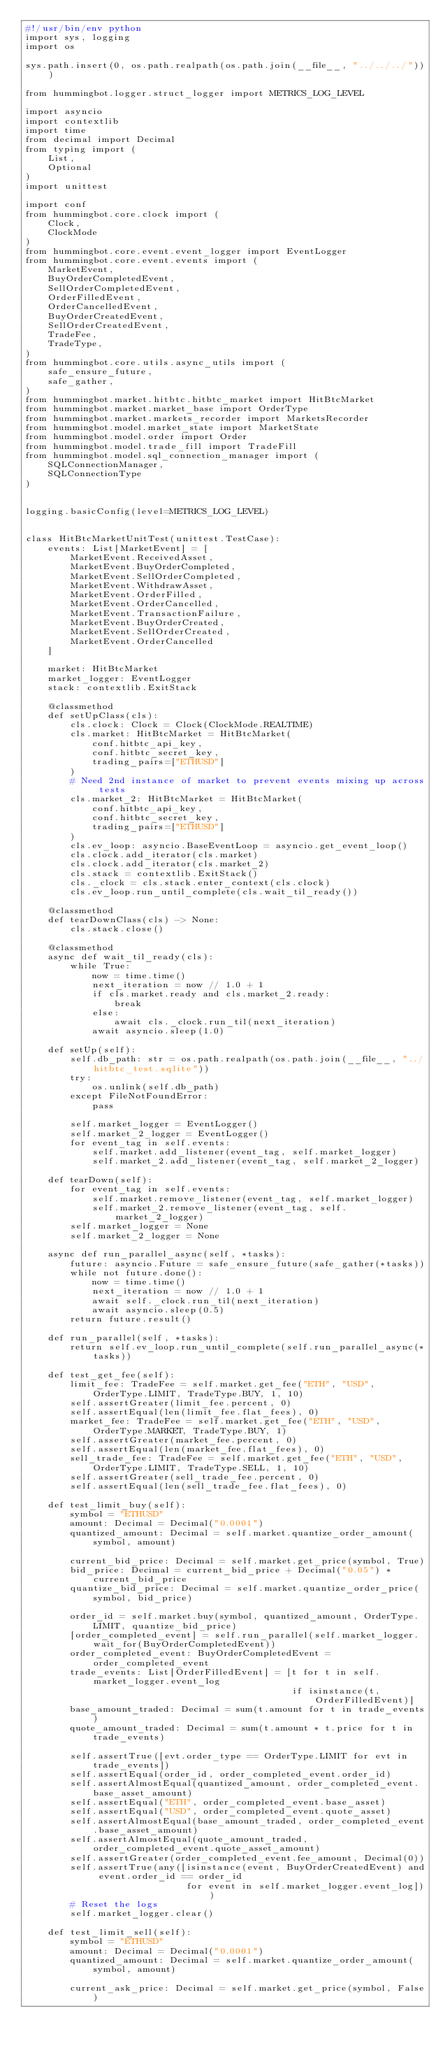<code> <loc_0><loc_0><loc_500><loc_500><_Python_>#!/usr/bin/env python
import sys, logging
import os

sys.path.insert(0, os.path.realpath(os.path.join(__file__, "../../../")))

from hummingbot.logger.struct_logger import METRICS_LOG_LEVEL

import asyncio
import contextlib
import time
from decimal import Decimal
from typing import (
    List,
    Optional
)
import unittest

import conf
from hummingbot.core.clock import (
    Clock,
    ClockMode
)
from hummingbot.core.event.event_logger import EventLogger
from hummingbot.core.event.events import (
    MarketEvent,
    BuyOrderCompletedEvent,
    SellOrderCompletedEvent,
    OrderFilledEvent,
    OrderCancelledEvent,
    BuyOrderCreatedEvent,
    SellOrderCreatedEvent,
    TradeFee,
    TradeType,
)
from hummingbot.core.utils.async_utils import (
    safe_ensure_future,
    safe_gather,
)
from hummingbot.market.hitbtc.hitbtc_market import HitBtcMarket
from hummingbot.market.market_base import OrderType
from hummingbot.market.markets_recorder import MarketsRecorder
from hummingbot.model.market_state import MarketState
from hummingbot.model.order import Order
from hummingbot.model.trade_fill import TradeFill
from hummingbot.model.sql_connection_manager import (
    SQLConnectionManager,
    SQLConnectionType
)


logging.basicConfig(level=METRICS_LOG_LEVEL)


class HitBtcMarketUnitTest(unittest.TestCase):
    events: List[MarketEvent] = [
        MarketEvent.ReceivedAsset,
        MarketEvent.BuyOrderCompleted,
        MarketEvent.SellOrderCompleted,
        MarketEvent.WithdrawAsset,
        MarketEvent.OrderFilled,
        MarketEvent.OrderCancelled,
        MarketEvent.TransactionFailure,
        MarketEvent.BuyOrderCreated,
        MarketEvent.SellOrderCreated,
        MarketEvent.OrderCancelled
    ]

    market: HitBtcMarket
    market_logger: EventLogger
    stack: contextlib.ExitStack

    @classmethod
    def setUpClass(cls):
        cls.clock: Clock = Clock(ClockMode.REALTIME)
        cls.market: HitBtcMarket = HitBtcMarket(
            conf.hitbtc_api_key,
            conf.hitbtc_secret_key,
            trading_pairs=["ETHUSD"]
        )
        # Need 2nd instance of market to prevent events mixing up across tests
        cls.market_2: HitBtcMarket = HitBtcMarket(
            conf.hitbtc_api_key,
            conf.hitbtc_secret_key,
            trading_pairs=["ETHUSD"]
        )
        cls.ev_loop: asyncio.BaseEventLoop = asyncio.get_event_loop()
        cls.clock.add_iterator(cls.market)
        cls.clock.add_iterator(cls.market_2)
        cls.stack = contextlib.ExitStack()
        cls._clock = cls.stack.enter_context(cls.clock)
        cls.ev_loop.run_until_complete(cls.wait_til_ready())

    @classmethod
    def tearDownClass(cls) -> None:
        cls.stack.close()

    @classmethod
    async def wait_til_ready(cls):
        while True:
            now = time.time()
            next_iteration = now // 1.0 + 1
            if cls.market.ready and cls.market_2.ready:
                break
            else:
                await cls._clock.run_til(next_iteration)
            await asyncio.sleep(1.0)

    def setUp(self):
        self.db_path: str = os.path.realpath(os.path.join(__file__, "../hitbtc_test.sqlite"))
        try:
            os.unlink(self.db_path)
        except FileNotFoundError:
            pass

        self.market_logger = EventLogger()
        self.market_2_logger = EventLogger()
        for event_tag in self.events:
            self.market.add_listener(event_tag, self.market_logger)
            self.market_2.add_listener(event_tag, self.market_2_logger)

    def tearDown(self):
        for event_tag in self.events:
            self.market.remove_listener(event_tag, self.market_logger)
            self.market_2.remove_listener(event_tag, self.market_2_logger)
        self.market_logger = None
        self.market_2_logger = None

    async def run_parallel_async(self, *tasks):
        future: asyncio.Future = safe_ensure_future(safe_gather(*tasks))
        while not future.done():
            now = time.time()
            next_iteration = now // 1.0 + 1
            await self._clock.run_til(next_iteration)
            await asyncio.sleep(0.5)
        return future.result()

    def run_parallel(self, *tasks):
        return self.ev_loop.run_until_complete(self.run_parallel_async(*tasks))

    def test_get_fee(self):
        limit_fee: TradeFee = self.market.get_fee("ETH", "USD", OrderType.LIMIT, TradeType.BUY, 1, 10)
        self.assertGreater(limit_fee.percent, 0)
        self.assertEqual(len(limit_fee.flat_fees), 0)
        market_fee: TradeFee = self.market.get_fee("ETH", "USD", OrderType.MARKET, TradeType.BUY, 1)
        self.assertGreater(market_fee.percent, 0)
        self.assertEqual(len(market_fee.flat_fees), 0)
        sell_trade_fee: TradeFee = self.market.get_fee("ETH", "USD", OrderType.LIMIT, TradeType.SELL, 1, 10)
        self.assertGreater(sell_trade_fee.percent, 0)
        self.assertEqual(len(sell_trade_fee.flat_fees), 0)

    def test_limit_buy(self):
        symbol = "ETHUSD"
        amount: Decimal = Decimal("0.0001")
        quantized_amount: Decimal = self.market.quantize_order_amount(symbol, amount)

        current_bid_price: Decimal = self.market.get_price(symbol, True)
        bid_price: Decimal = current_bid_price + Decimal("0.05") * current_bid_price
        quantize_bid_price: Decimal = self.market.quantize_order_price(symbol, bid_price)

        order_id = self.market.buy(symbol, quantized_amount, OrderType.LIMIT, quantize_bid_price)
        [order_completed_event] = self.run_parallel(self.market_logger.wait_for(BuyOrderCompletedEvent))
        order_completed_event: BuyOrderCompletedEvent = order_completed_event
        trade_events: List[OrderFilledEvent] = [t for t in self.market_logger.event_log
                                                if isinstance(t, OrderFilledEvent)]
        base_amount_traded: Decimal = sum(t.amount for t in trade_events)
        quote_amount_traded: Decimal = sum(t.amount * t.price for t in trade_events)

        self.assertTrue([evt.order_type == OrderType.LIMIT for evt in trade_events])
        self.assertEqual(order_id, order_completed_event.order_id)
        self.assertAlmostEqual(quantized_amount, order_completed_event.base_asset_amount)
        self.assertEqual("ETH", order_completed_event.base_asset)
        self.assertEqual("USD", order_completed_event.quote_asset)
        self.assertAlmostEqual(base_amount_traded, order_completed_event.base_asset_amount)
        self.assertAlmostEqual(quote_amount_traded, order_completed_event.quote_asset_amount)
        self.assertGreater(order_completed_event.fee_amount, Decimal(0))
        self.assertTrue(any([isinstance(event, BuyOrderCreatedEvent) and event.order_id == order_id
                             for event in self.market_logger.event_log]))
        # Reset the logs
        self.market_logger.clear()

    def test_limit_sell(self):
        symbol = "ETHUSD"
        amount: Decimal = Decimal("0.0001")
        quantized_amount: Decimal = self.market.quantize_order_amount(symbol, amount)

        current_ask_price: Decimal = self.market.get_price(symbol, False)</code> 